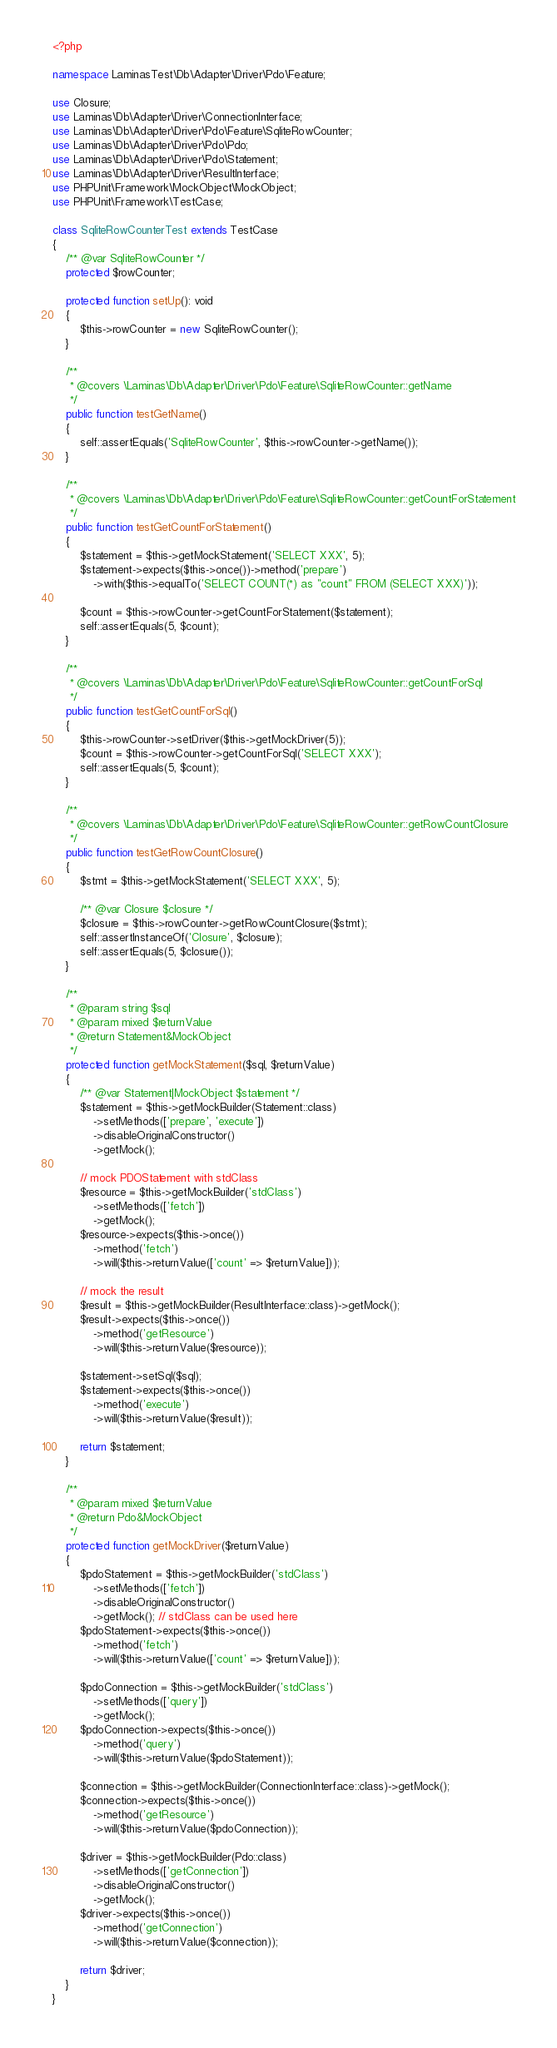Convert code to text. <code><loc_0><loc_0><loc_500><loc_500><_PHP_><?php

namespace LaminasTest\Db\Adapter\Driver\Pdo\Feature;

use Closure;
use Laminas\Db\Adapter\Driver\ConnectionInterface;
use Laminas\Db\Adapter\Driver\Pdo\Feature\SqliteRowCounter;
use Laminas\Db\Adapter\Driver\Pdo\Pdo;
use Laminas\Db\Adapter\Driver\Pdo\Statement;
use Laminas\Db\Adapter\Driver\ResultInterface;
use PHPUnit\Framework\MockObject\MockObject;
use PHPUnit\Framework\TestCase;

class SqliteRowCounterTest extends TestCase
{
    /** @var SqliteRowCounter */
    protected $rowCounter;

    protected function setUp(): void
    {
        $this->rowCounter = new SqliteRowCounter();
    }

    /**
     * @covers \Laminas\Db\Adapter\Driver\Pdo\Feature\SqliteRowCounter::getName
     */
    public function testGetName()
    {
        self::assertEquals('SqliteRowCounter', $this->rowCounter->getName());
    }

    /**
     * @covers \Laminas\Db\Adapter\Driver\Pdo\Feature\SqliteRowCounter::getCountForStatement
     */
    public function testGetCountForStatement()
    {
        $statement = $this->getMockStatement('SELECT XXX', 5);
        $statement->expects($this->once())->method('prepare')
            ->with($this->equalTo('SELECT COUNT(*) as "count" FROM (SELECT XXX)'));

        $count = $this->rowCounter->getCountForStatement($statement);
        self::assertEquals(5, $count);
    }

    /**
     * @covers \Laminas\Db\Adapter\Driver\Pdo\Feature\SqliteRowCounter::getCountForSql
     */
    public function testGetCountForSql()
    {
        $this->rowCounter->setDriver($this->getMockDriver(5));
        $count = $this->rowCounter->getCountForSql('SELECT XXX');
        self::assertEquals(5, $count);
    }

    /**
     * @covers \Laminas\Db\Adapter\Driver\Pdo\Feature\SqliteRowCounter::getRowCountClosure
     */
    public function testGetRowCountClosure()
    {
        $stmt = $this->getMockStatement('SELECT XXX', 5);

        /** @var Closure $closure */
        $closure = $this->rowCounter->getRowCountClosure($stmt);
        self::assertInstanceOf('Closure', $closure);
        self::assertEquals(5, $closure());
    }

    /**
     * @param string $sql
     * @param mixed $returnValue
     * @return Statement&MockObject
     */
    protected function getMockStatement($sql, $returnValue)
    {
        /** @var Statement|MockObject $statement */
        $statement = $this->getMockBuilder(Statement::class)
            ->setMethods(['prepare', 'execute'])
            ->disableOriginalConstructor()
            ->getMock();

        // mock PDOStatement with stdClass
        $resource = $this->getMockBuilder('stdClass')
            ->setMethods(['fetch'])
            ->getMock();
        $resource->expects($this->once())
            ->method('fetch')
            ->will($this->returnValue(['count' => $returnValue]));

        // mock the result
        $result = $this->getMockBuilder(ResultInterface::class)->getMock();
        $result->expects($this->once())
            ->method('getResource')
            ->will($this->returnValue($resource));

        $statement->setSql($sql);
        $statement->expects($this->once())
            ->method('execute')
            ->will($this->returnValue($result));

        return $statement;
    }

    /**
     * @param mixed $returnValue
     * @return Pdo&MockObject
     */
    protected function getMockDriver($returnValue)
    {
        $pdoStatement = $this->getMockBuilder('stdClass')
            ->setMethods(['fetch'])
            ->disableOriginalConstructor()
            ->getMock(); // stdClass can be used here
        $pdoStatement->expects($this->once())
            ->method('fetch')
            ->will($this->returnValue(['count' => $returnValue]));

        $pdoConnection = $this->getMockBuilder('stdClass')
            ->setMethods(['query'])
            ->getMock();
        $pdoConnection->expects($this->once())
            ->method('query')
            ->will($this->returnValue($pdoStatement));

        $connection = $this->getMockBuilder(ConnectionInterface::class)->getMock();
        $connection->expects($this->once())
            ->method('getResource')
            ->will($this->returnValue($pdoConnection));

        $driver = $this->getMockBuilder(Pdo::class)
            ->setMethods(['getConnection'])
            ->disableOriginalConstructor()
            ->getMock();
        $driver->expects($this->once())
            ->method('getConnection')
            ->will($this->returnValue($connection));

        return $driver;
    }
}
</code> 